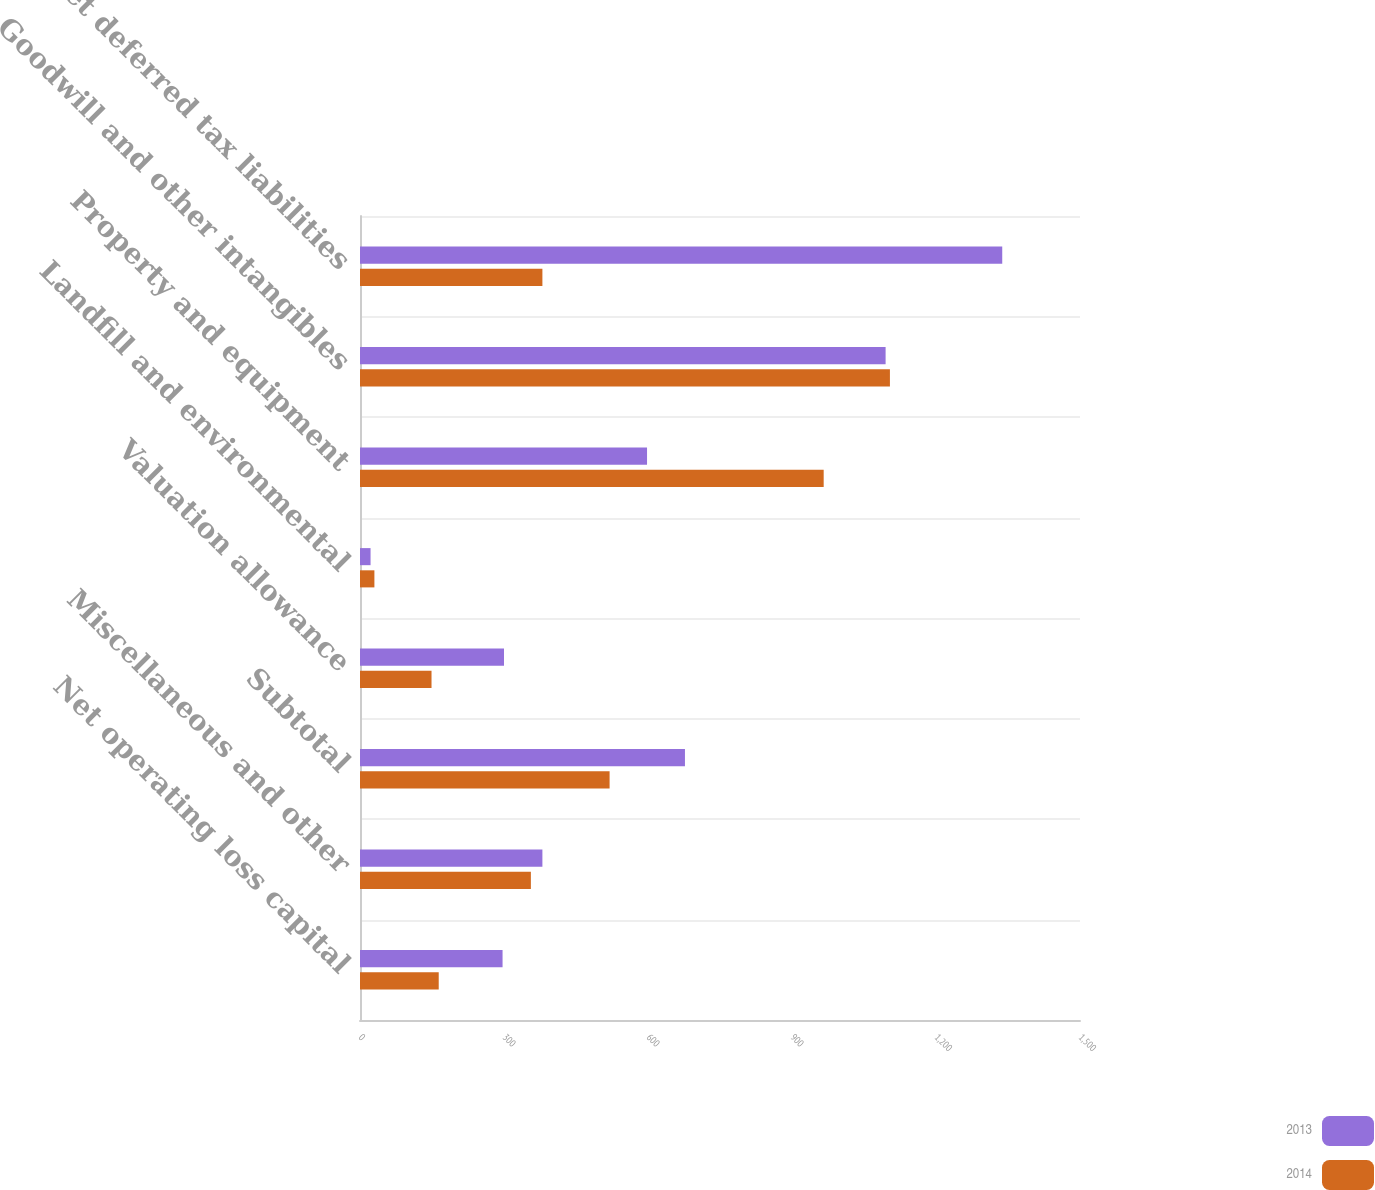Convert chart to OTSL. <chart><loc_0><loc_0><loc_500><loc_500><stacked_bar_chart><ecel><fcel>Net operating loss capital<fcel>Miscellaneous and other<fcel>Subtotal<fcel>Valuation allowance<fcel>Landfill and environmental<fcel>Property and equipment<fcel>Goodwill and other intangibles<fcel>Net deferred tax liabilities<nl><fcel>2013<fcel>297<fcel>380<fcel>677<fcel>300<fcel>22<fcel>598<fcel>1095<fcel>1338<nl><fcel>2014<fcel>164<fcel>356<fcel>520<fcel>149<fcel>30<fcel>966<fcel>1104<fcel>380<nl></chart> 